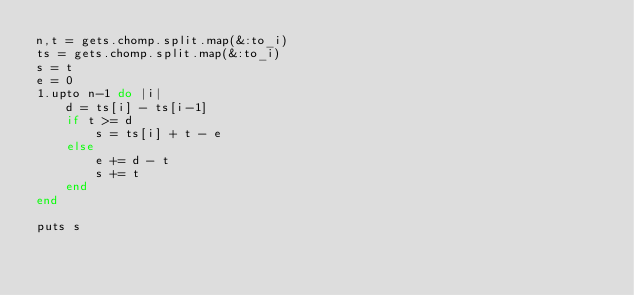<code> <loc_0><loc_0><loc_500><loc_500><_Ruby_>n,t = gets.chomp.split.map(&:to_i)
ts = gets.chomp.split.map(&:to_i)
s = t
e = 0
1.upto n-1 do |i|
    d = ts[i] - ts[i-1]
    if t >= d
        s = ts[i] + t - e
    else
        e += d - t
        s += t
    end
end

puts s
</code> 